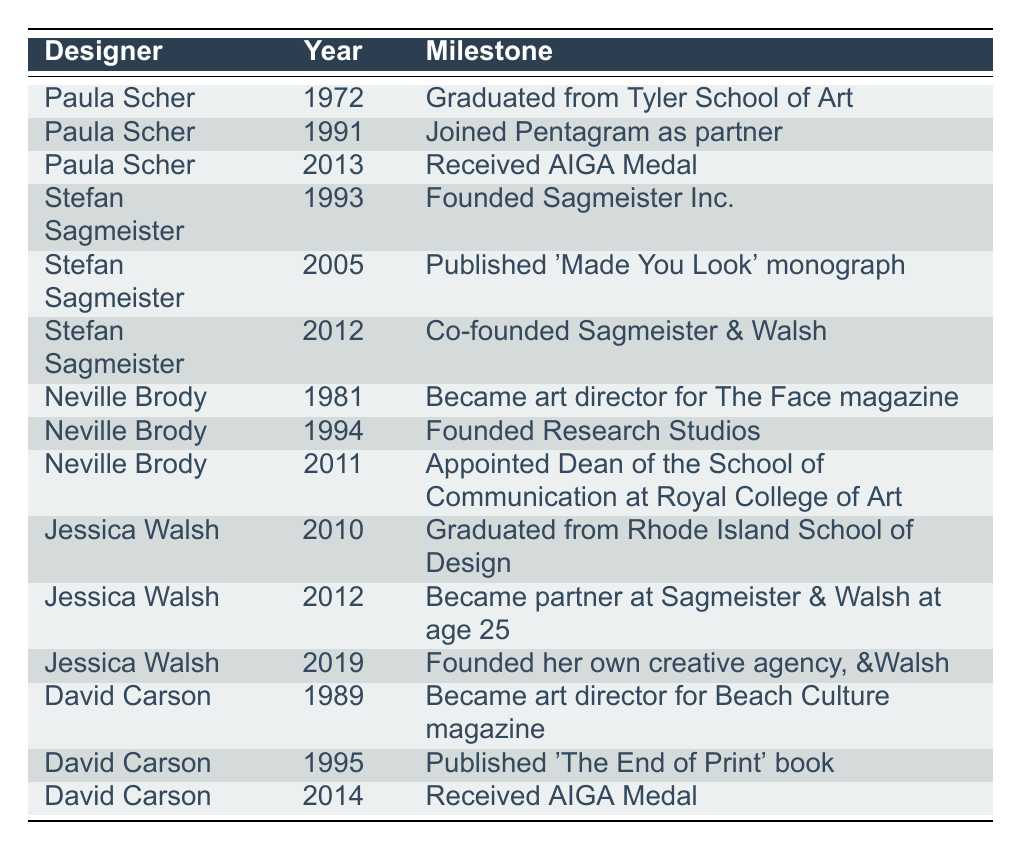What milestone did Paula Scher achieve in 2013? In the table, under Paula Scher's entry for the year 2013, it states that she received the AIGA Medal.
Answer: Received AIGA Medal How many milestones are listed for Jessica Walsh in the table? By reviewing the entries under Jessica Walsh, there are three milestones: graduating from RISD in 2010, becoming a partner in 2012, and founding her own agency in 2019.
Answer: Three Which designer became an art director for The Face magazine, and in what year? Looking at the entry for Neville Brody, it shows that he became an art director for The Face magazine in 1981.
Answer: Neville Brody, 1981 What was the year when David Carson published 'The End of Print'? The table indicates that David Carson published 'The End of Print' in 1995.
Answer: 1995 How many years passed between Paula Scher's graduation and her joining Pentagram as a partner? Paula Scher graduated in 1972 and joined Pentagram in 1991, so the difference is 1991 - 1972 = 19 years.
Answer: 19 years Did Stefan Sagmeister found his own studio before or after 2000? By checking the milestones for Stefan Sagmeister, he founded Sagmeister Inc. in 1993, which is before 2000.
Answer: Before 2000 Who were the designers that received the AIGA Medal, and in what years did they receive it? The table shows that Paula Scher received the AIGA Medal in 2013 and David Carson received it in 2014, thus both received it in different years.
Answer: Paula Scher (2013), David Carson (2014) What is the chronological order of milestones for Jessica Walsh? The milestones for Jessica Walsh, in chronological order, are graduating from RISD in 2010, becoming a partner at Sagmeister & Walsh in 2012, and founding her own agency in 2019.
Answer: 2010, 2012, 2019 Which designer had the earliest milestone listed in the table? The earliest milestone listed is for Paula Scher, who graduated in 1972, making her the designer with the earliest milestone.
Answer: Paula Scher, 1972 How many designers listed achieved their milestones in the 2010s? Reviewing the milestones in the 2010s, Paula Scher's AIGA Medal in 2013, Jessica Walsh's milestones in 2012 and 2019, and David Carson's milestone in 2014 totals four milestones by three designers: Scher, Walsh, and Carson.
Answer: Four milestones What was Neville Brody's final milestone in the table? The last milestone listed for Neville Brody is his appointment as Dean of the School of Communication at the Royal College of Art in 2011.
Answer: Appointed Dean in 2011 